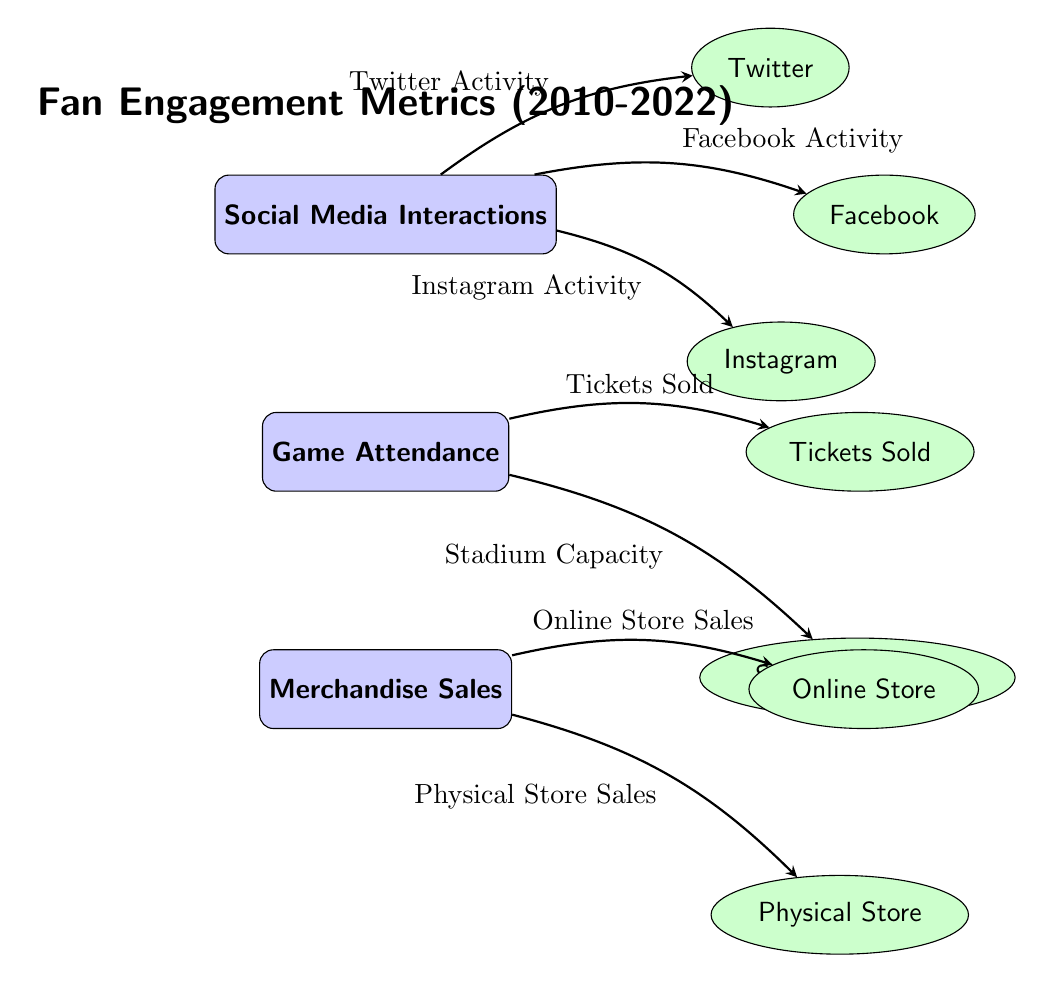What are the main metrics displayed in this diagram? The diagram displays three main metrics: Social Media Interactions, Game Attendance, and Merchandise Sales. Each metric is represented by a main node.
Answer: Social Media Interactions, Game Attendance, Merchandise Sales Which social media platforms are included in the diagram? The diagram includes three social media platforms: Facebook, Twitter, and Instagram, represented as sub-nodes branching from Social Media Interactions.
Answer: Facebook, Twitter, Instagram How many sub-nodes are associated with Game Attendance? There are two sub-nodes associated with Game Attendance: Tickets Sold and Stadium Capacity. These represent the aspects related to attendance.
Answer: 2 What is the relationship between Social Media Interactions and Twitter? The relationship indicates that Twitter Activity is derived from Social Media Interactions, as illustrated by the arrow pointing from Social Media Interactions to Twitter.
Answer: Twitter Activity What does the edge between Merchandise Sales and Online Store represent? The edge indicates that Online Store Sales are a component of Merchandise Sales, visually showing the flow and interaction between these aspects.
Answer: Online Store Sales If Game Attendance increases, what is expected to happen to Tickets Sold? An increase in Game Attendance would result in more Tickets Sold, as the two concepts are directly linked in the diagram with an arrow indicating flow.
Answer: Tickets Sold Which node has the most sub-nodes? The Social Media Interactions node has the most sub-nodes, with three branches leading to its associated platforms: Facebook, Twitter, and Instagram.
Answer: Social Media Interactions What type of diagram is this? This diagram is a Textbook Diagram, structured to clearly represent metrics and their interrelationships, ideal for educational purposes.
Answer: Textbook Diagram How do Merchandise Sales relate to Physical Store? The Physical Store Sales are a sub-component of Merchandise Sales, indicating the relationship that links them through an arrow in the diagram.
Answer: Physical Store Sales 